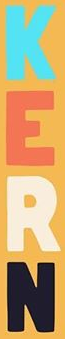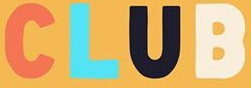Read the text from these images in sequence, separated by a semicolon. KERN; CLUB 